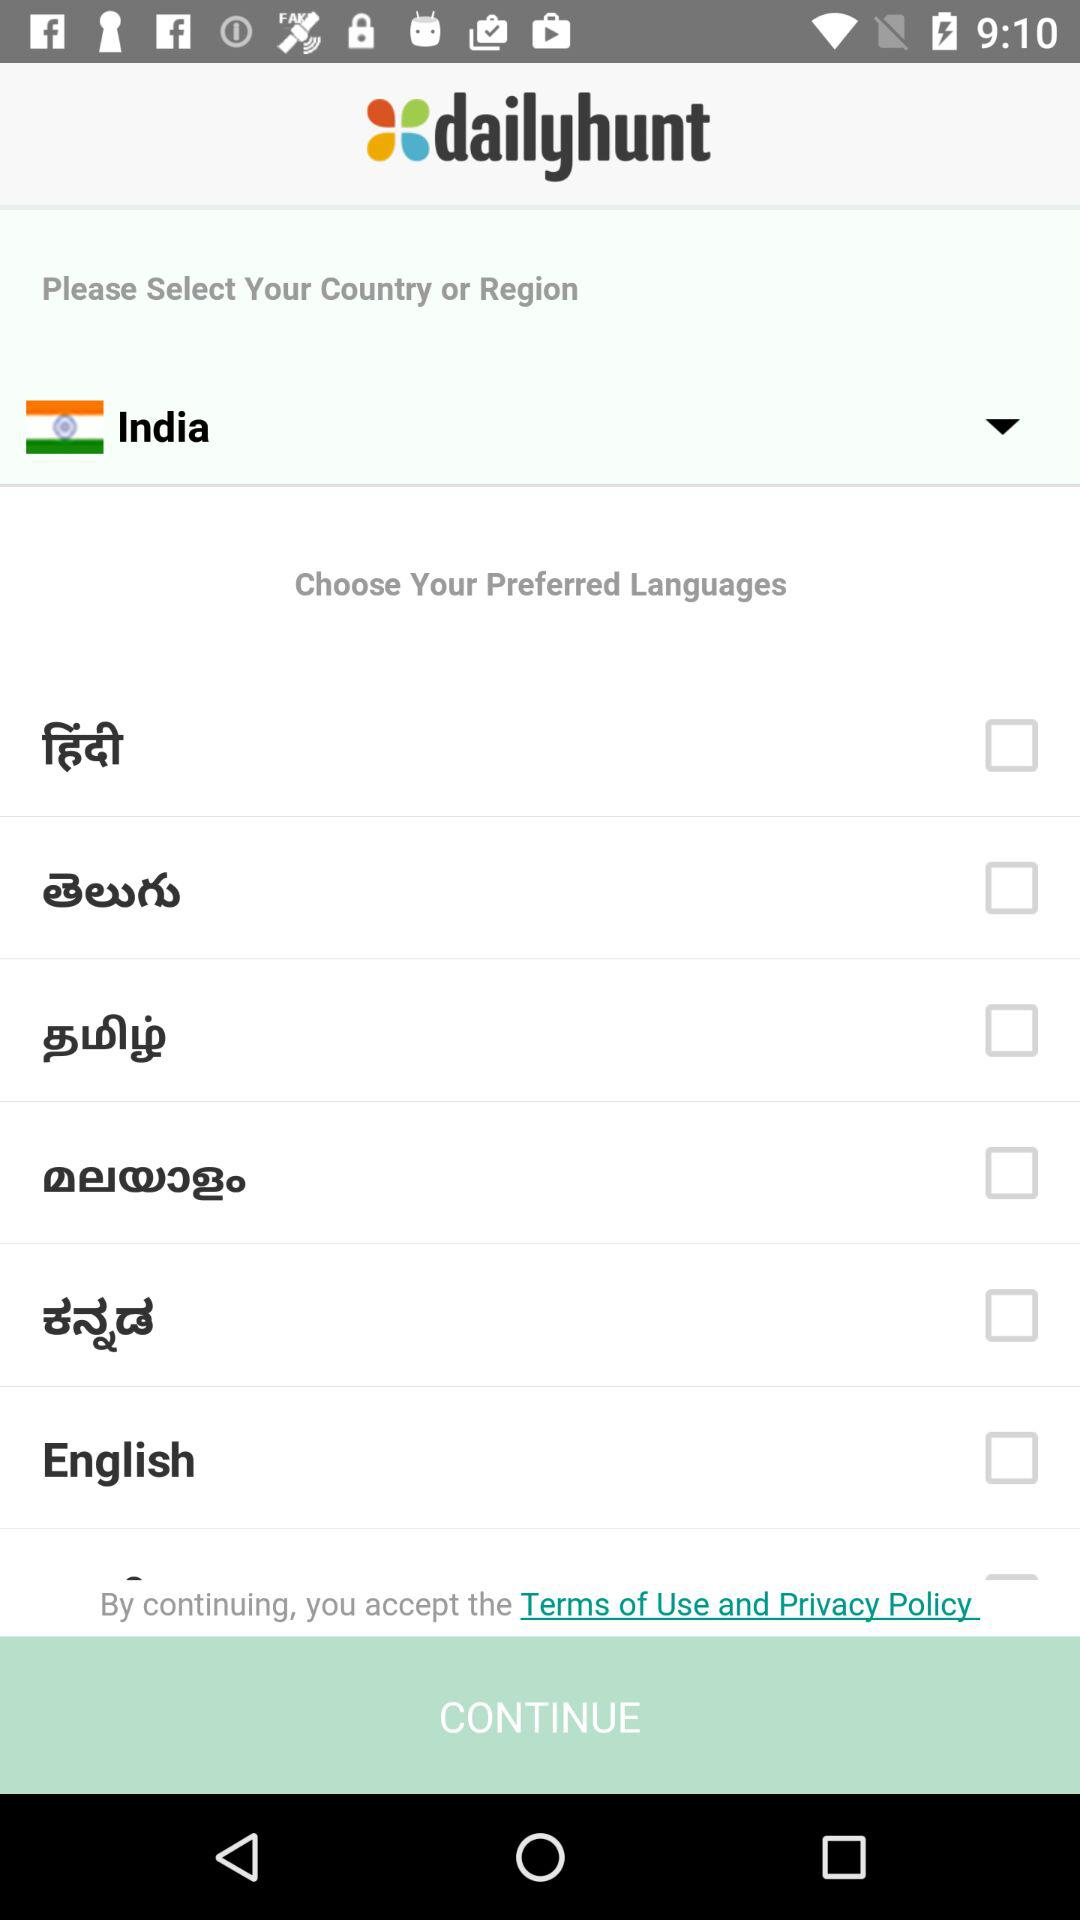What is the status of the "English"? The status is "off". 